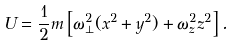<formula> <loc_0><loc_0><loc_500><loc_500>U = \frac { 1 } { 2 } m \left [ \omega _ { \perp } ^ { 2 } ( x ^ { 2 } + y ^ { 2 } ) + \omega _ { z } ^ { 2 } z ^ { 2 } \right ] .</formula> 